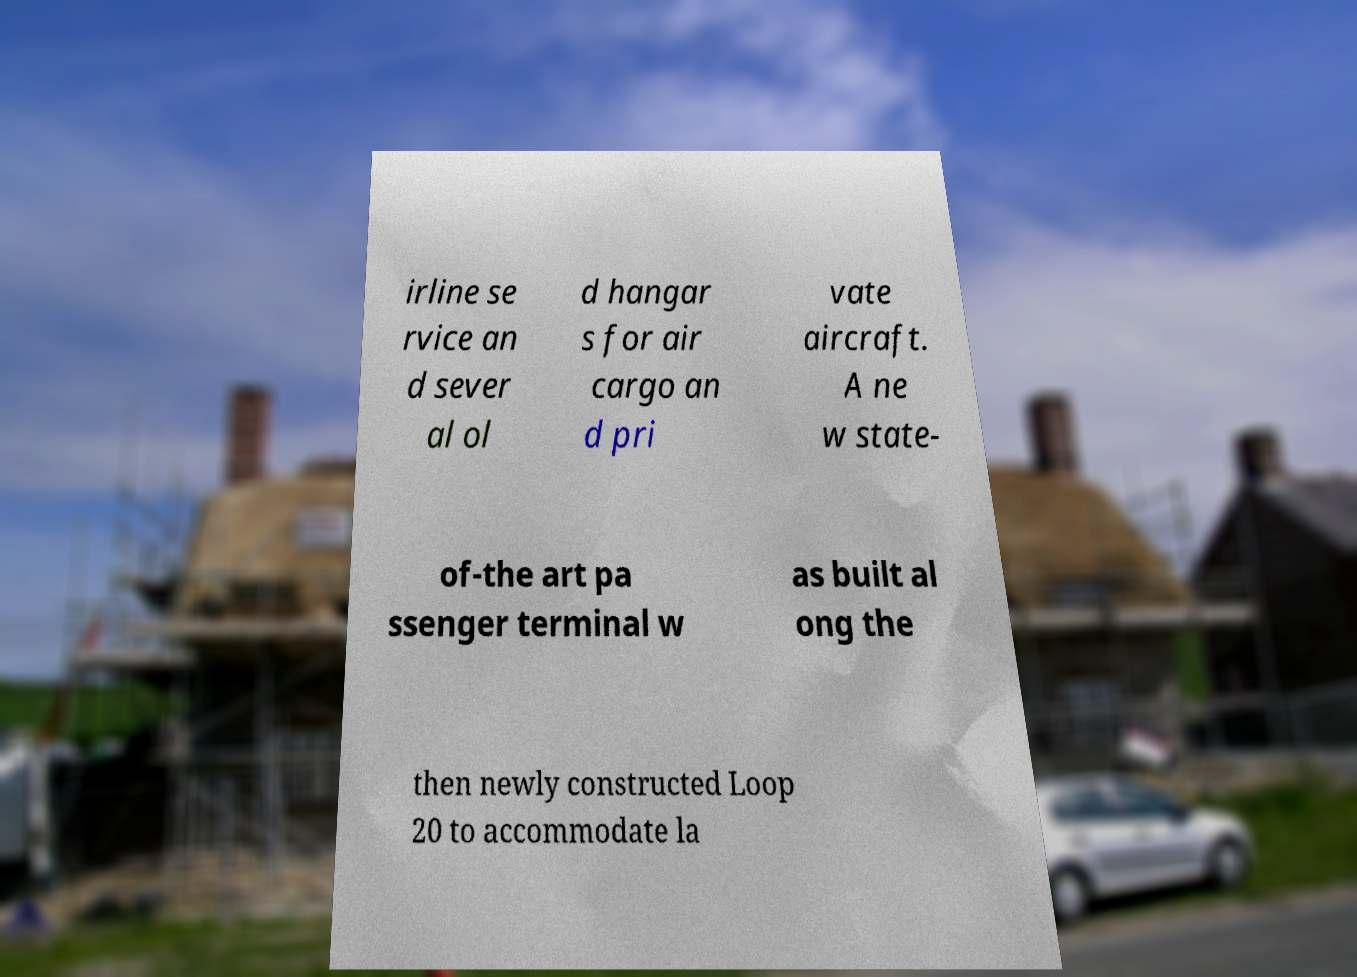For documentation purposes, I need the text within this image transcribed. Could you provide that? irline se rvice an d sever al ol d hangar s for air cargo an d pri vate aircraft. A ne w state- of-the art pa ssenger terminal w as built al ong the then newly constructed Loop 20 to accommodate la 